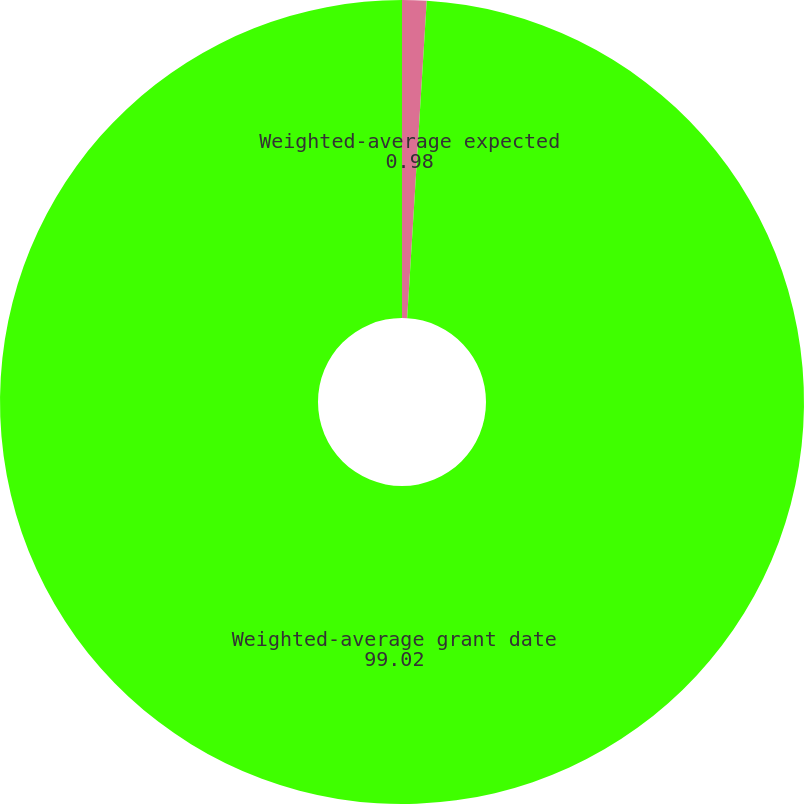<chart> <loc_0><loc_0><loc_500><loc_500><pie_chart><fcel>Weighted-average expected<fcel>Weighted-average grant date<nl><fcel>0.98%<fcel>99.02%<nl></chart> 